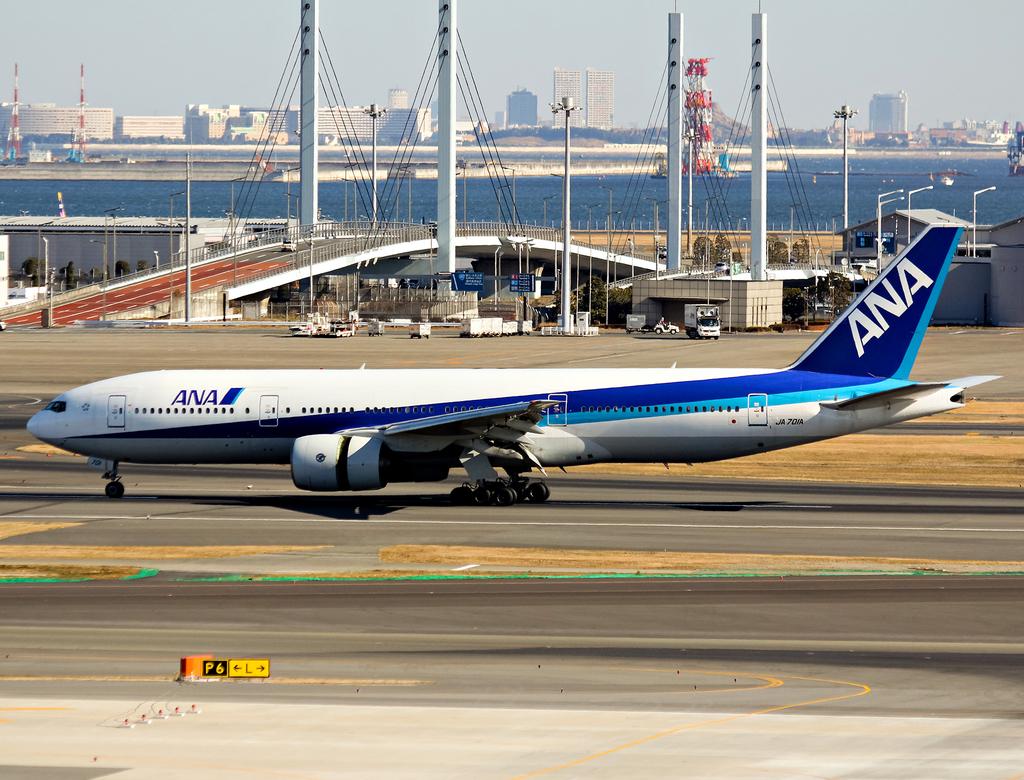What airline flies this plane?
Ensure brevity in your answer.  Ana. What is written on the small yellow and black sign below the plane?
Your answer should be very brief. P6 l. 